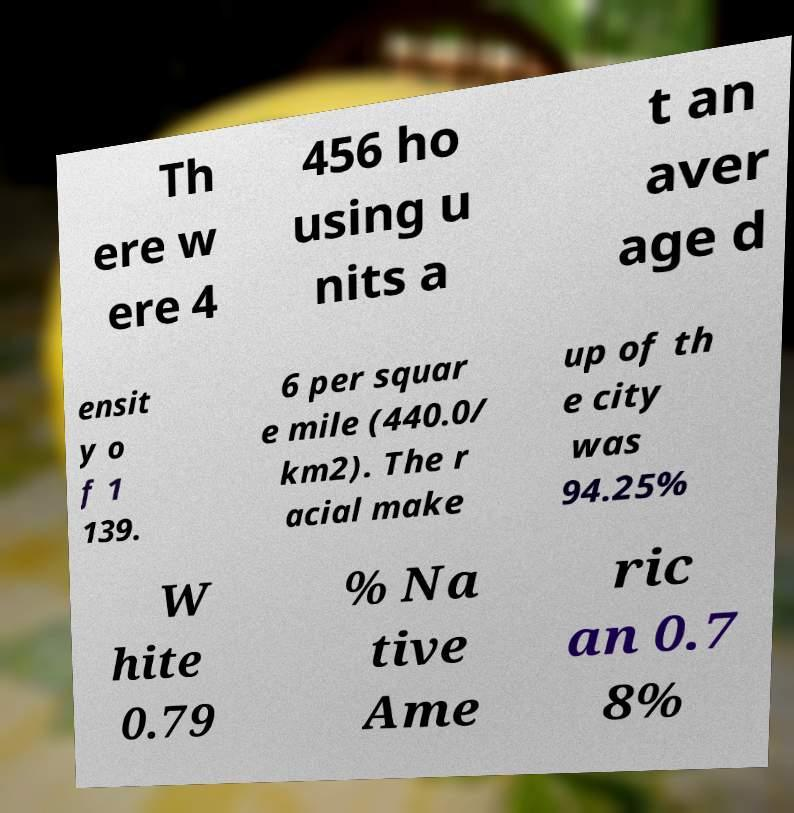What messages or text are displayed in this image? I need them in a readable, typed format. Th ere w ere 4 456 ho using u nits a t an aver age d ensit y o f 1 139. 6 per squar e mile (440.0/ km2). The r acial make up of th e city was 94.25% W hite 0.79 % Na tive Ame ric an 0.7 8% 